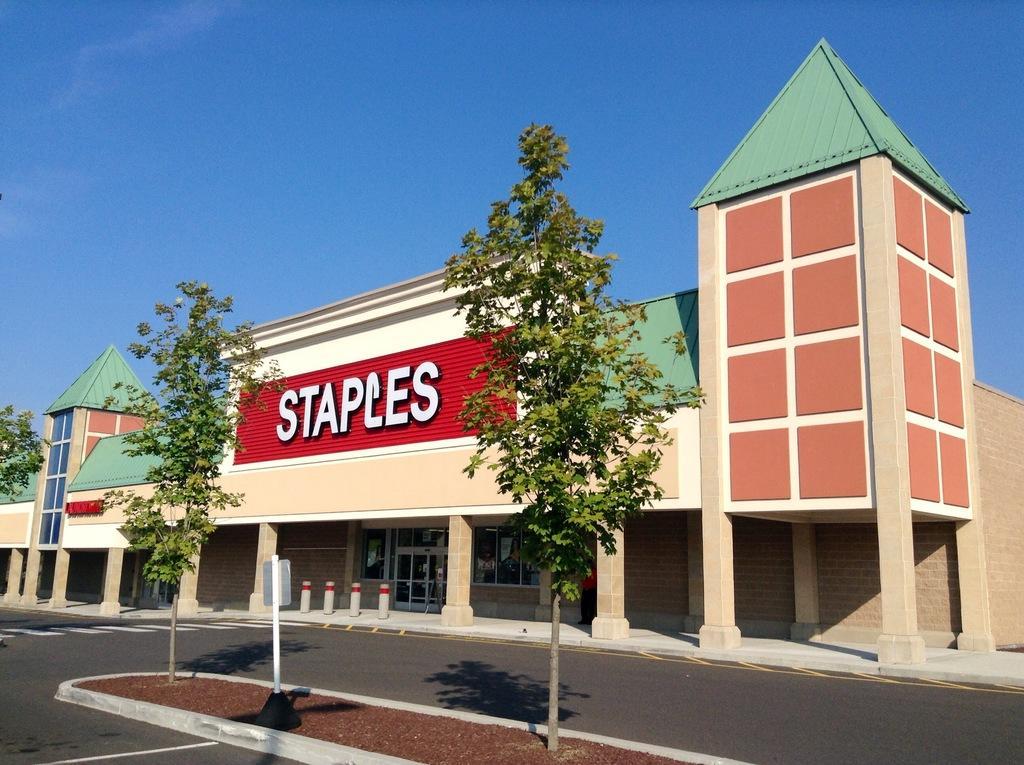Describe this image in one or two sentences. This picture is clicked outside the city. In front of the picture, we see the trees and a pole. At the bottom, we see the road and the soil. In the background, we see a building with a green color roof. In the middle of the picture, we see a red board with "STAPLE" written on it. At the top, we see the sky, which is blue in color. 